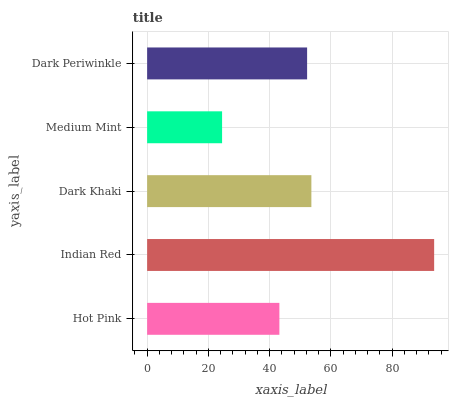Is Medium Mint the minimum?
Answer yes or no. Yes. Is Indian Red the maximum?
Answer yes or no. Yes. Is Dark Khaki the minimum?
Answer yes or no. No. Is Dark Khaki the maximum?
Answer yes or no. No. Is Indian Red greater than Dark Khaki?
Answer yes or no. Yes. Is Dark Khaki less than Indian Red?
Answer yes or no. Yes. Is Dark Khaki greater than Indian Red?
Answer yes or no. No. Is Indian Red less than Dark Khaki?
Answer yes or no. No. Is Dark Periwinkle the high median?
Answer yes or no. Yes. Is Dark Periwinkle the low median?
Answer yes or no. Yes. Is Dark Khaki the high median?
Answer yes or no. No. Is Medium Mint the low median?
Answer yes or no. No. 